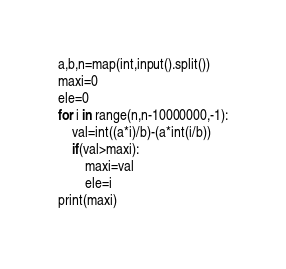<code> <loc_0><loc_0><loc_500><loc_500><_Python_>a,b,n=map(int,input().split())
maxi=0
ele=0
for i in range(n,n-10000000,-1):
    val=int((a*i)/b)-(a*int(i/b))
    if(val>maxi):
        maxi=val
        ele=i
print(maxi)</code> 